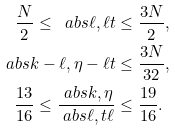Convert formula to latex. <formula><loc_0><loc_0><loc_500><loc_500>\frac { N } { 2 } \leq \ a b s { \ell , \ell t } & \leq \frac { 3 N } { 2 } , \\ \ a b s { k - \ell , \eta - \ell t } & \leq \frac { 3 N } { 3 2 } , \\ \frac { 1 3 } { 1 6 } \leq \frac { \ a b s { k , \eta } } { \ a b s { \ell , t \ell } } & \leq \frac { 1 9 } { 1 6 } .</formula> 